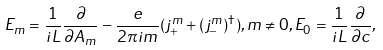<formula> <loc_0><loc_0><loc_500><loc_500>E _ { m } = \frac { 1 } { i L } \frac { \partial } { \partial A _ { m } } - \frac { e } { 2 \pi i m } ( j _ { + } ^ { m } + ( j _ { - } ^ { m } ) ^ { \dagger } ) , m \neq 0 , E _ { 0 } = \frac { 1 } { i L } \frac { \partial } { \partial c } ,</formula> 